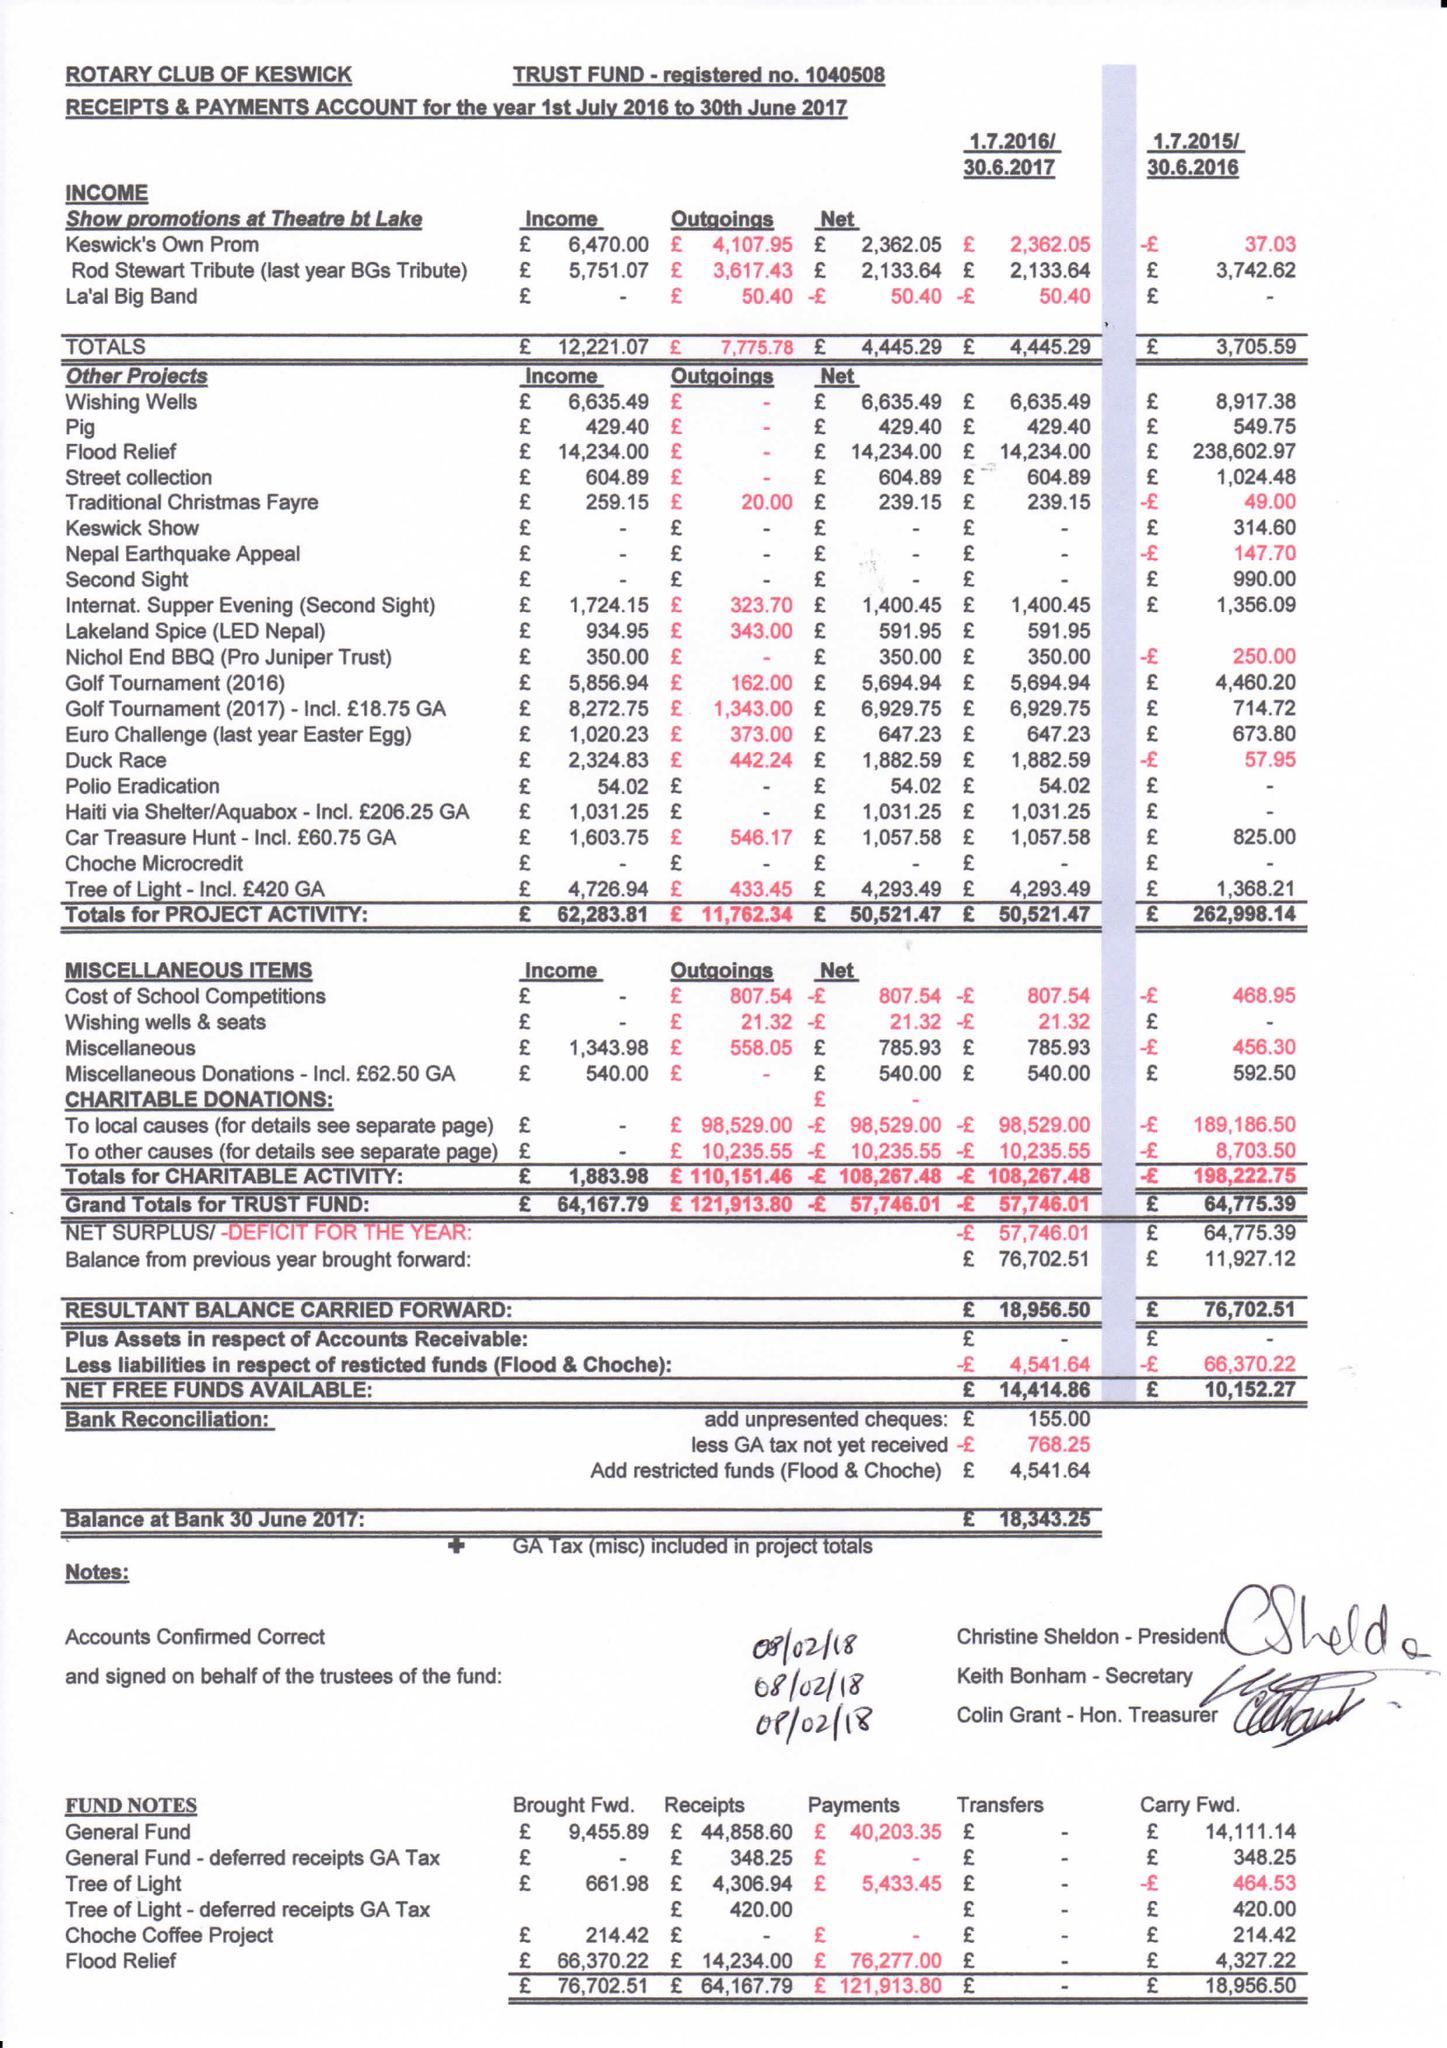What is the value for the charity_name?
Answer the question using a single word or phrase. Rotary Club Of Keswick Trust Fund 